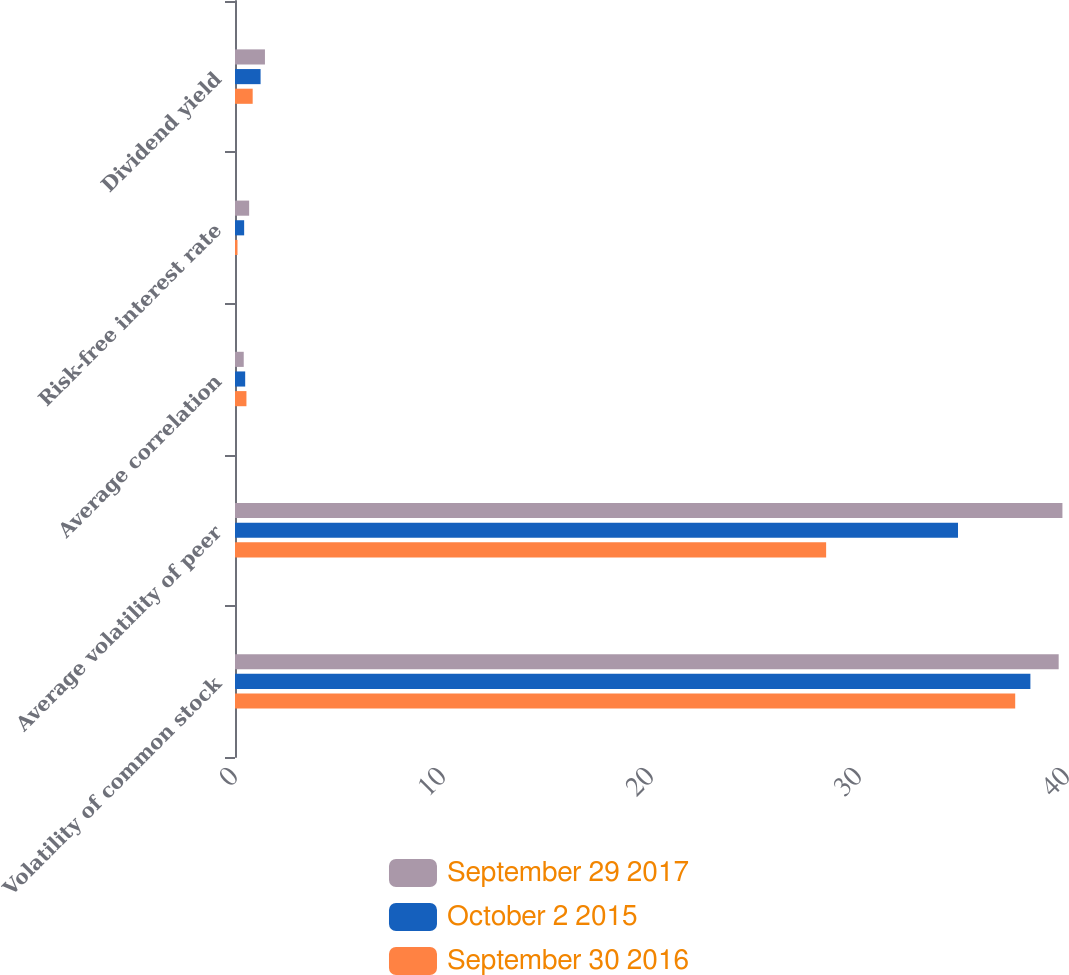Convert chart. <chart><loc_0><loc_0><loc_500><loc_500><stacked_bar_chart><ecel><fcel>Volatility of common stock<fcel>Average volatility of peer<fcel>Average correlation<fcel>Risk-free interest rate<fcel>Dividend yield<nl><fcel>September 29 2017<fcel>39.6<fcel>39.78<fcel>0.42<fcel>0.68<fcel>1.44<nl><fcel>October 2 2015<fcel>38.24<fcel>34.76<fcel>0.49<fcel>0.44<fcel>1.23<nl><fcel>September 30 2016<fcel>37.51<fcel>28.42<fcel>0.55<fcel>0.12<fcel>0.85<nl></chart> 